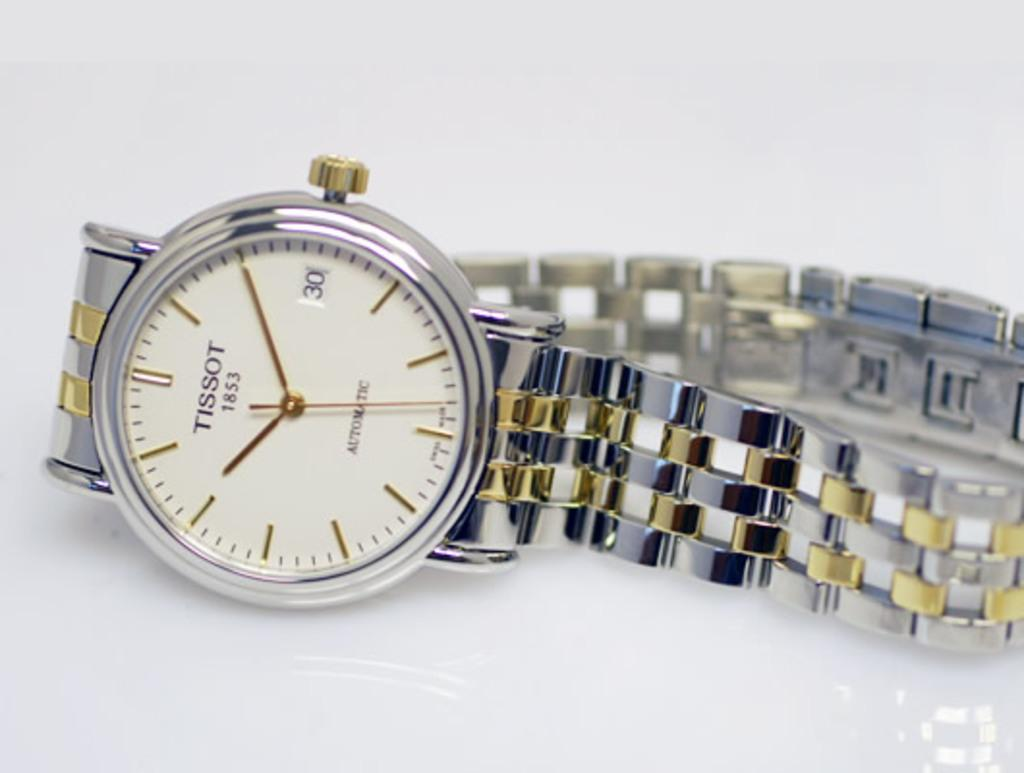<image>
Offer a succinct explanation of the picture presented. A Tissot 1853 watch is on display against a white background. 